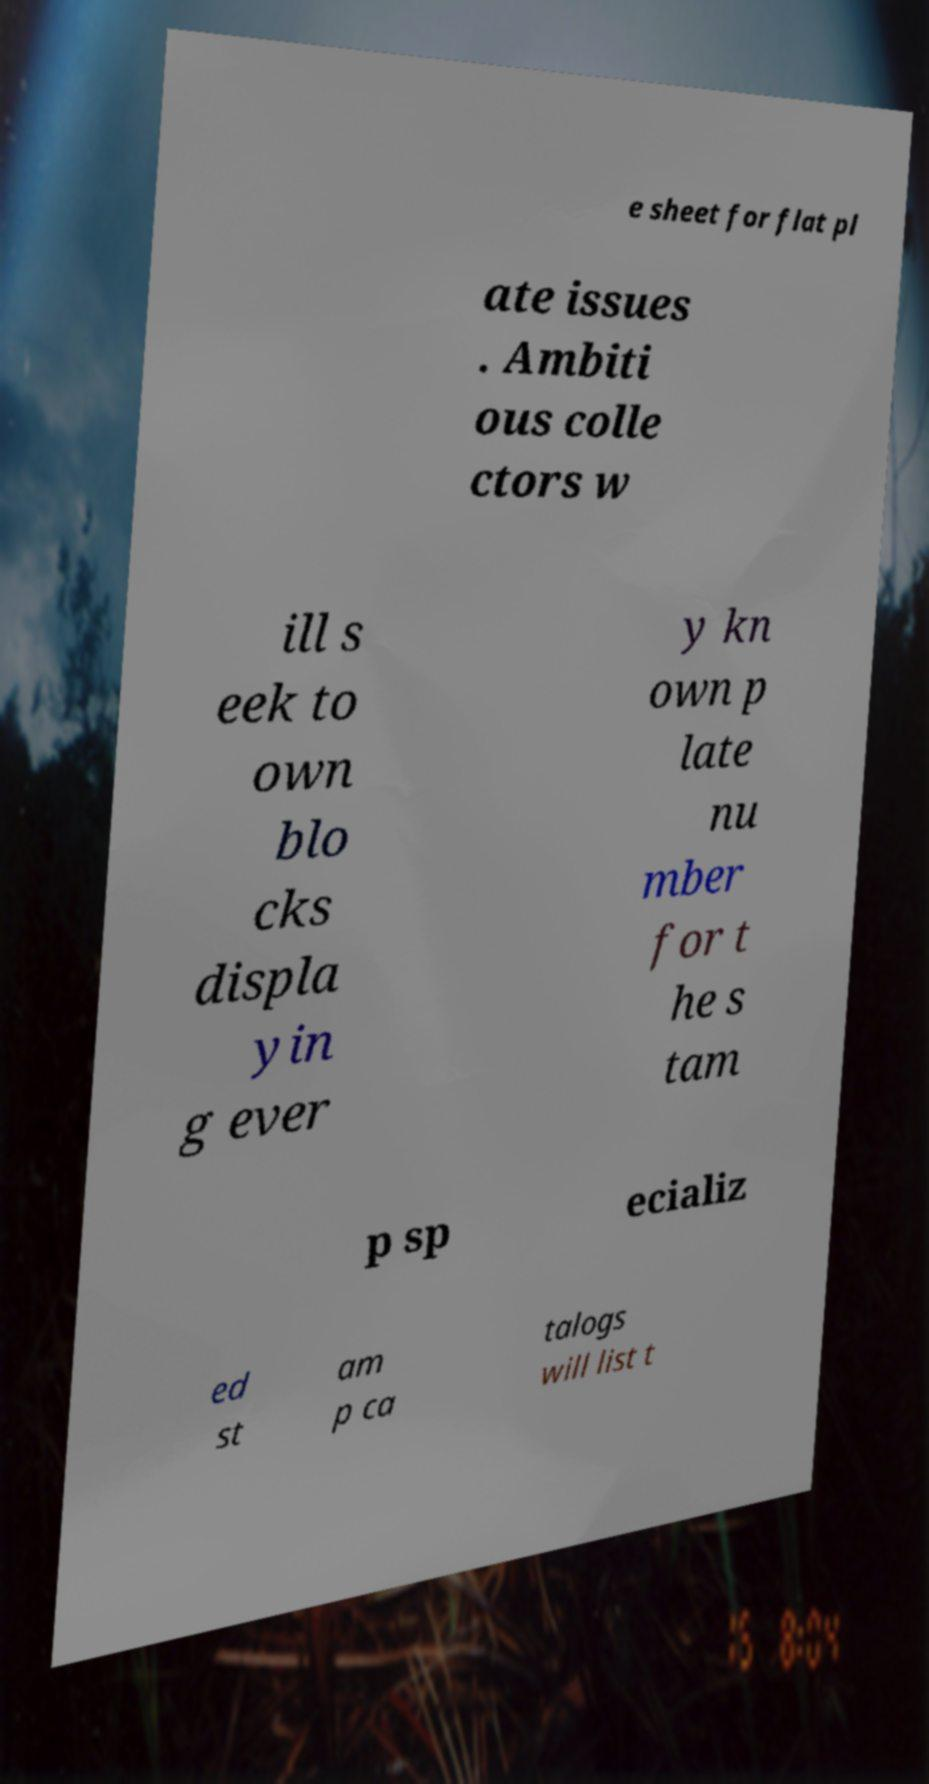Could you assist in decoding the text presented in this image and type it out clearly? e sheet for flat pl ate issues . Ambiti ous colle ctors w ill s eek to own blo cks displa yin g ever y kn own p late nu mber for t he s tam p sp ecializ ed st am p ca talogs will list t 